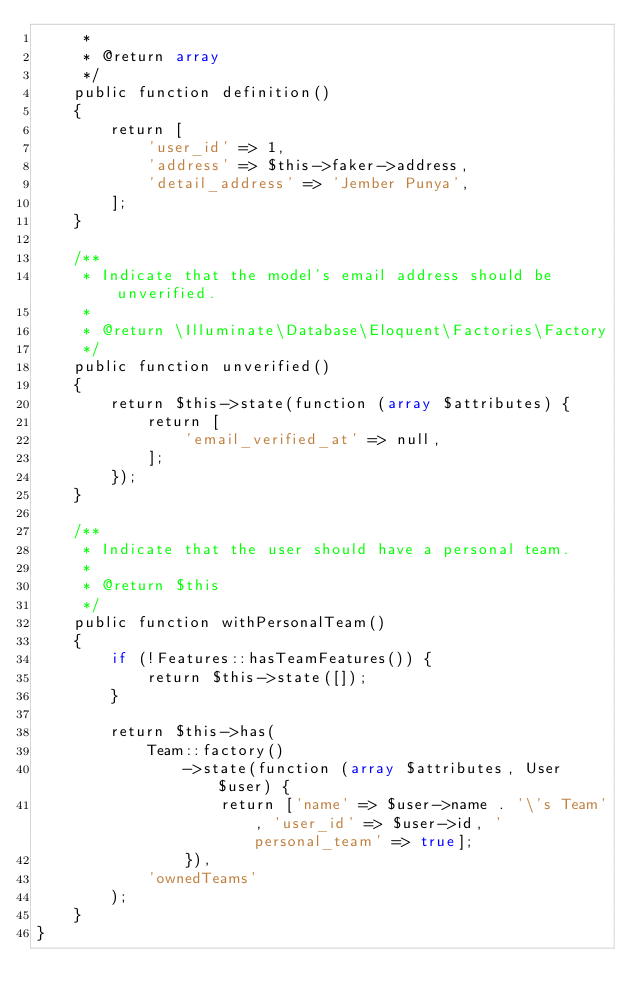<code> <loc_0><loc_0><loc_500><loc_500><_PHP_>     *
     * @return array
     */
    public function definition()
    {
        return [
            'user_id' => 1,
            'address' => $this->faker->address,
            'detail_address' => 'Jember Punya',
        ];
    }

    /**
     * Indicate that the model's email address should be unverified.
     *
     * @return \Illuminate\Database\Eloquent\Factories\Factory
     */
    public function unverified()
    {
        return $this->state(function (array $attributes) {
            return [
                'email_verified_at' => null,
            ];
        });
    }

    /**
     * Indicate that the user should have a personal team.
     *
     * @return $this
     */
    public function withPersonalTeam()
    {
        if (!Features::hasTeamFeatures()) {
            return $this->state([]);
        }

        return $this->has(
            Team::factory()
                ->state(function (array $attributes, User $user) {
                    return ['name' => $user->name . '\'s Team', 'user_id' => $user->id, 'personal_team' => true];
                }),
            'ownedTeams'
        );
    }
}
</code> 